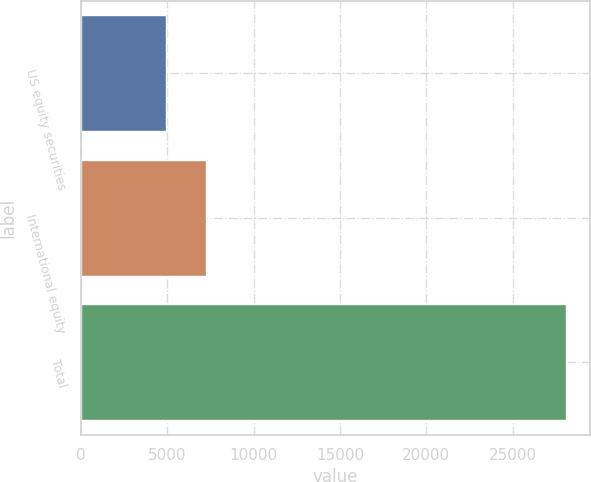<chart> <loc_0><loc_0><loc_500><loc_500><bar_chart><fcel>US equity securities<fcel>International equity<fcel>Total<nl><fcel>4922<fcel>7238.5<fcel>28087<nl></chart> 